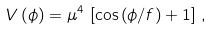<formula> <loc_0><loc_0><loc_500><loc_500>V \left ( \phi \right ) = \mu ^ { 4 } \, \left [ \cos \left ( \phi / f \right ) + 1 \right ] \, ,</formula> 